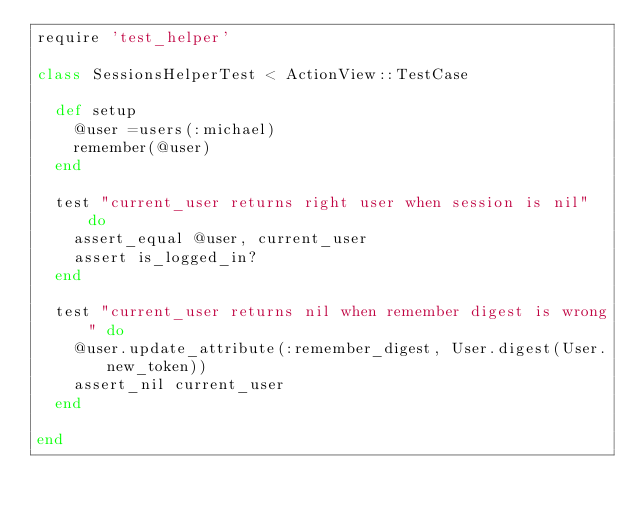Convert code to text. <code><loc_0><loc_0><loc_500><loc_500><_Ruby_>require 'test_helper'

class SessionsHelperTest < ActionView::TestCase

  def setup
    @user =users(:michael)
    remember(@user)
  end

  test "current_user returns right user when session is nil" do
    assert_equal @user, current_user
    assert is_logged_in?
  end

  test "current_user returns nil when remember digest is wrong" do
    @user.update_attribute(:remember_digest, User.digest(User.new_token))
    assert_nil current_user
  end

end
</code> 